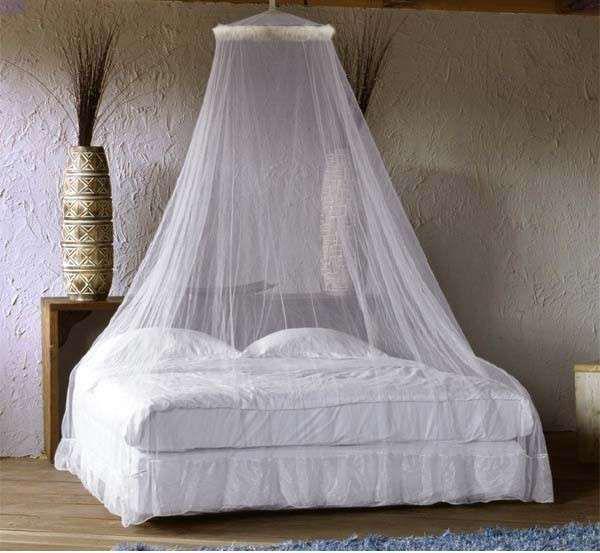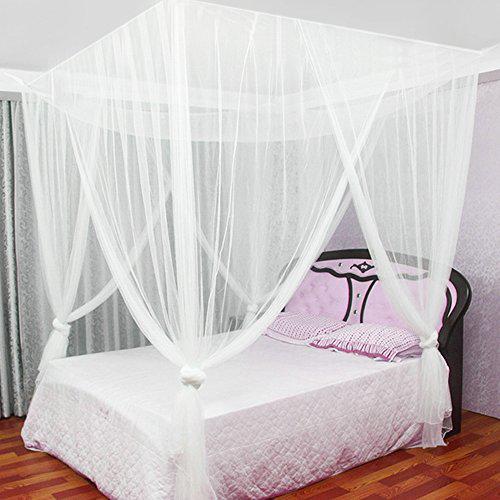The first image is the image on the left, the second image is the image on the right. Assess this claim about the two images: "The left and right image contains the same number of canopies one circle and one square.". Correct or not? Answer yes or no. Yes. The first image is the image on the left, the second image is the image on the right. Given the left and right images, does the statement "There is exactly one round canopy." hold true? Answer yes or no. Yes. 